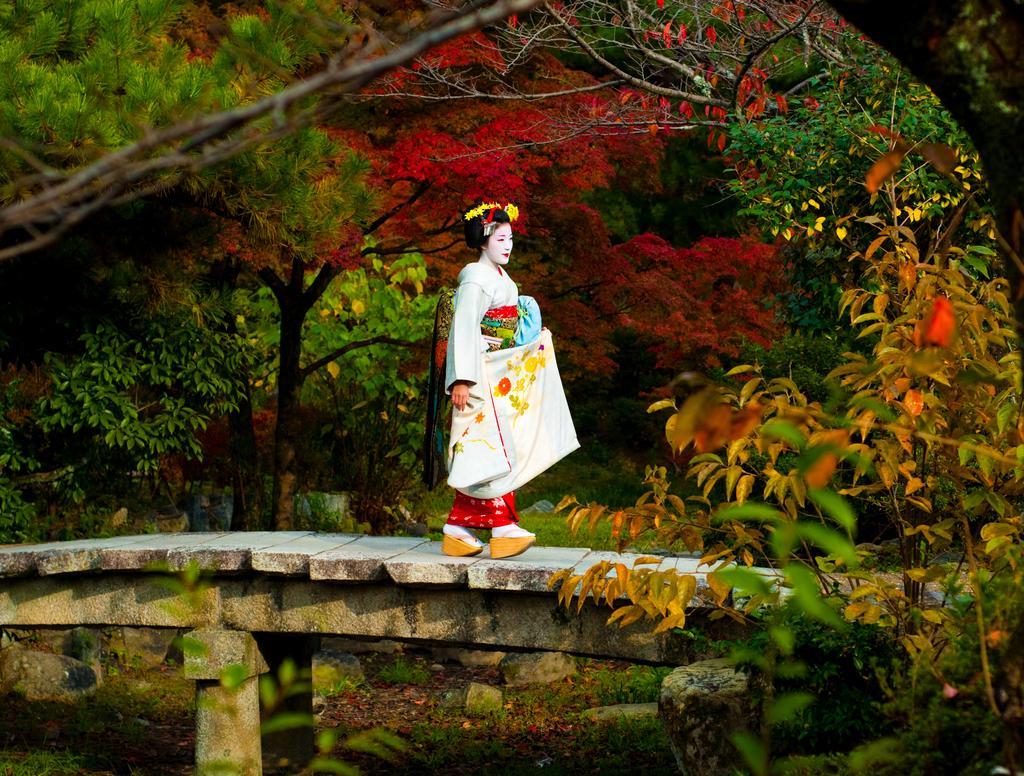Please provide a concise description of this image. In the picture I can see a woman walking on the wooden walkway. In the background, I can see the trees. 